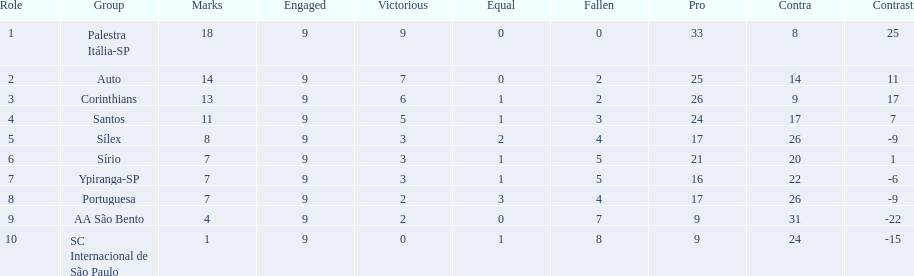Brazilian football in 1926 what teams had no draws? Palestra Itália-SP, Auto, AA São Bento. Of the teams with no draws name the 2 who lost the lease. Palestra Itália-SP, Auto. What team of the 2 who lost the least and had no draws had the highest difference? Palestra Itália-SP. 